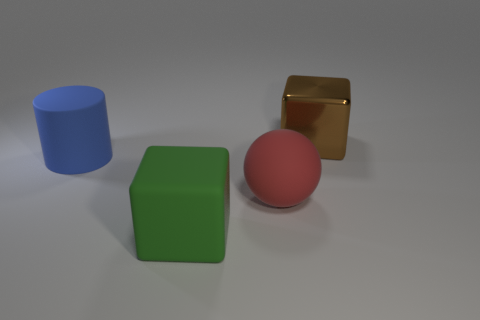Add 4 green matte blocks. How many objects exist? 8 Subtract all spheres. How many objects are left? 3 Subtract 1 red balls. How many objects are left? 3 Subtract all large yellow spheres. Subtract all metal blocks. How many objects are left? 3 Add 1 balls. How many balls are left? 2 Add 1 big blue matte cylinders. How many big blue matte cylinders exist? 2 